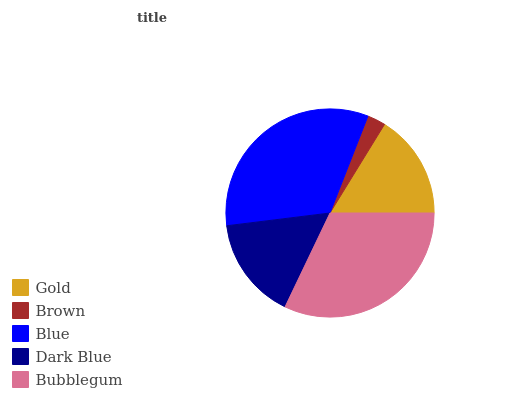Is Brown the minimum?
Answer yes or no. Yes. Is Blue the maximum?
Answer yes or no. Yes. Is Blue the minimum?
Answer yes or no. No. Is Brown the maximum?
Answer yes or no. No. Is Blue greater than Brown?
Answer yes or no. Yes. Is Brown less than Blue?
Answer yes or no. Yes. Is Brown greater than Blue?
Answer yes or no. No. Is Blue less than Brown?
Answer yes or no. No. Is Gold the high median?
Answer yes or no. Yes. Is Gold the low median?
Answer yes or no. Yes. Is Brown the high median?
Answer yes or no. No. Is Bubblegum the low median?
Answer yes or no. No. 